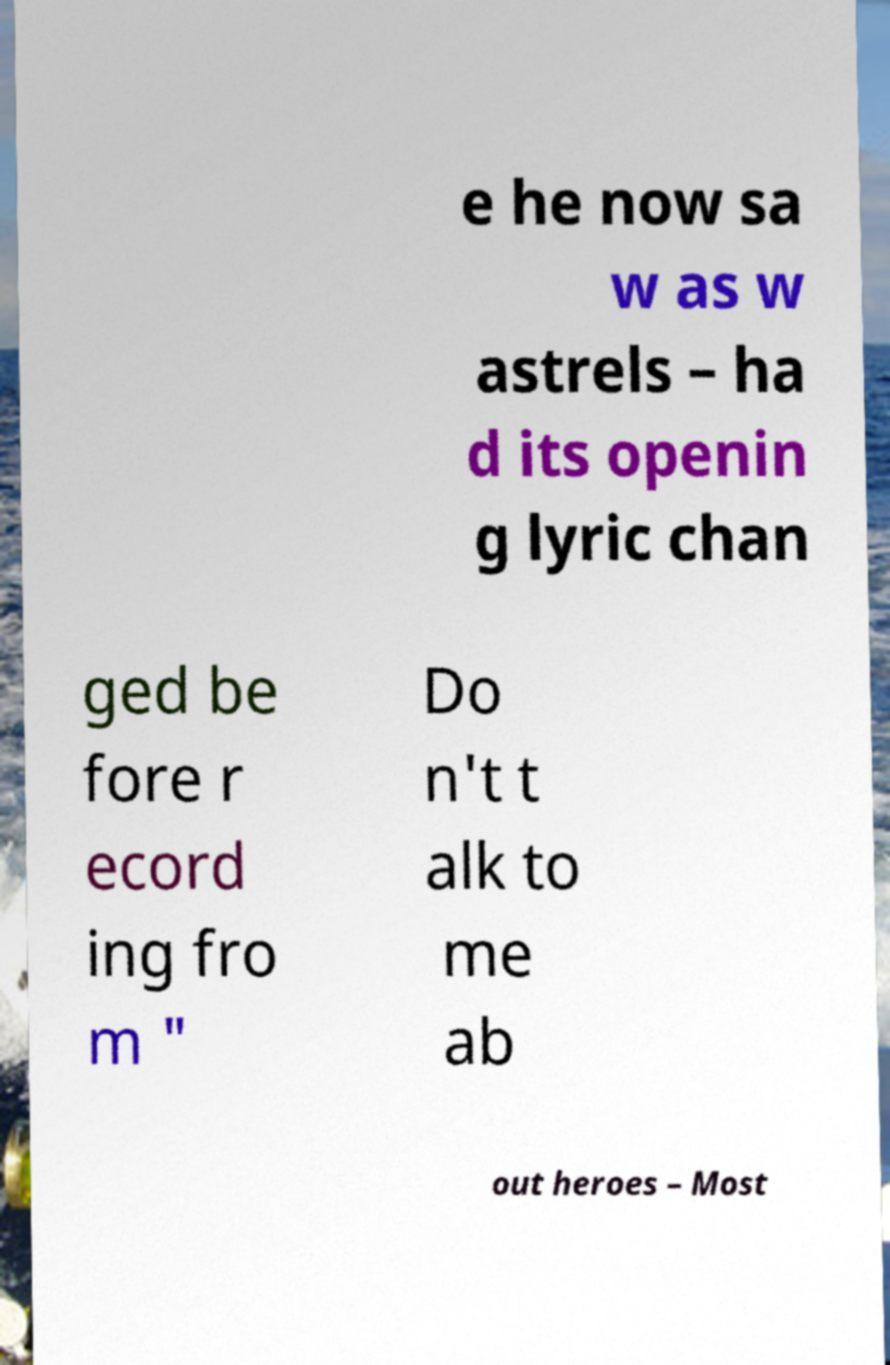There's text embedded in this image that I need extracted. Can you transcribe it verbatim? e he now sa w as w astrels – ha d its openin g lyric chan ged be fore r ecord ing fro m " Do n't t alk to me ab out heroes – Most 